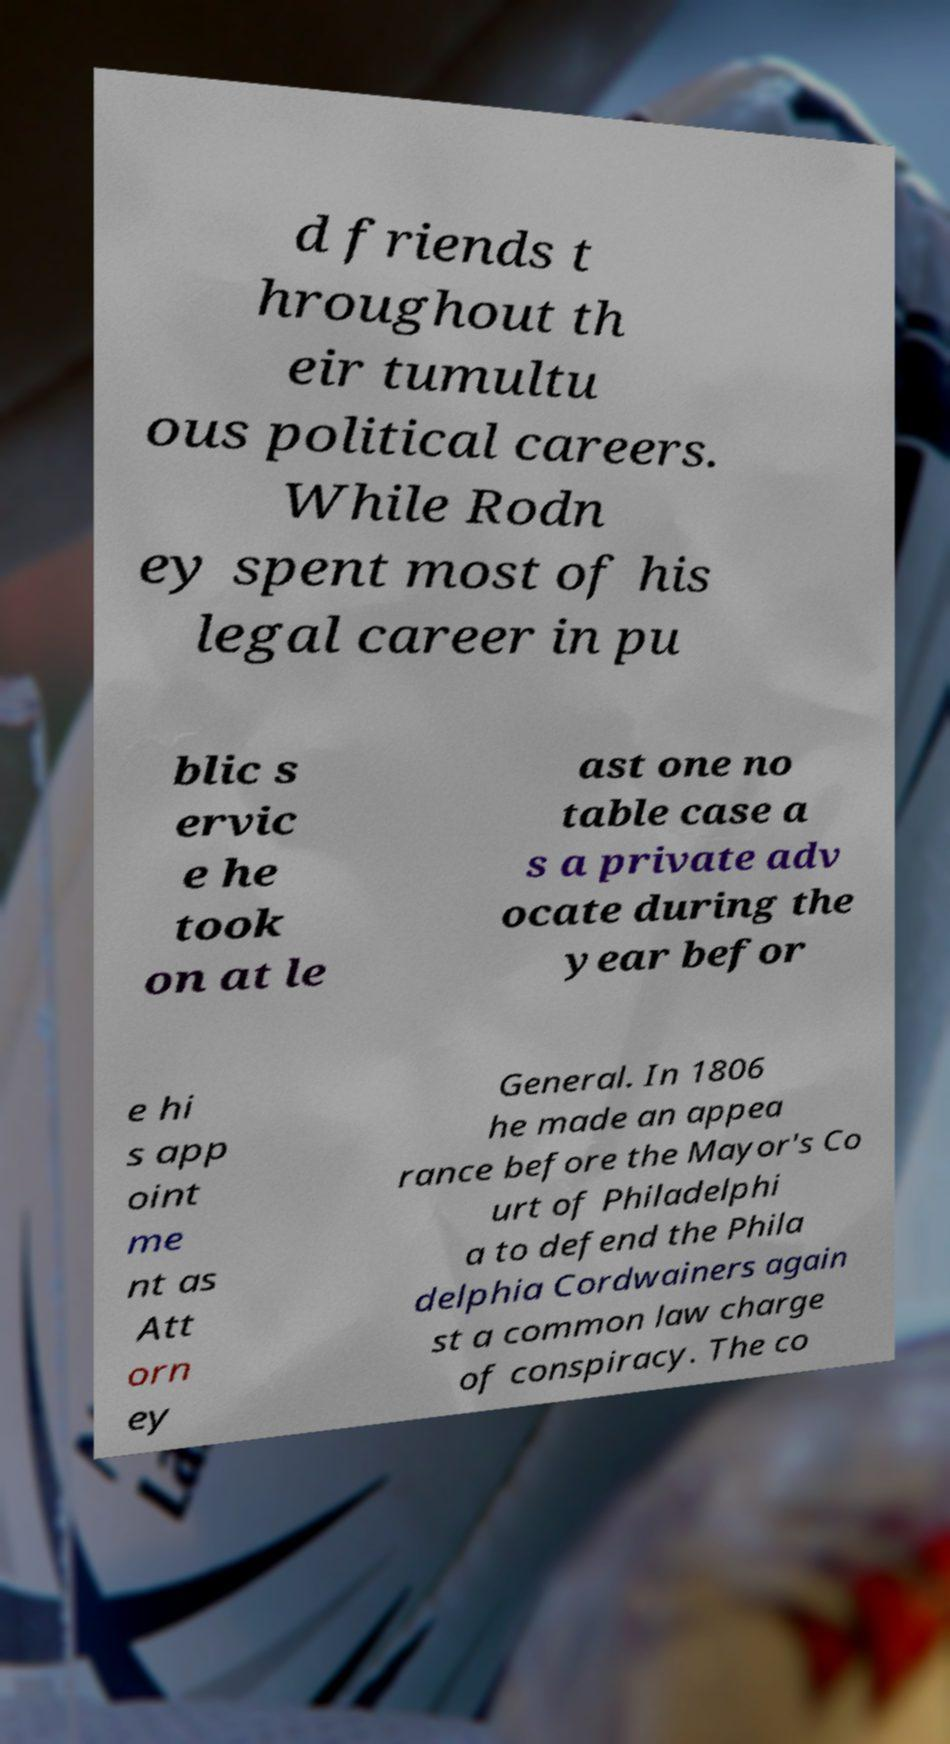For documentation purposes, I need the text within this image transcribed. Could you provide that? d friends t hroughout th eir tumultu ous political careers. While Rodn ey spent most of his legal career in pu blic s ervic e he took on at le ast one no table case a s a private adv ocate during the year befor e hi s app oint me nt as Att orn ey General. In 1806 he made an appea rance before the Mayor's Co urt of Philadelphi a to defend the Phila delphia Cordwainers again st a common law charge of conspiracy. The co 